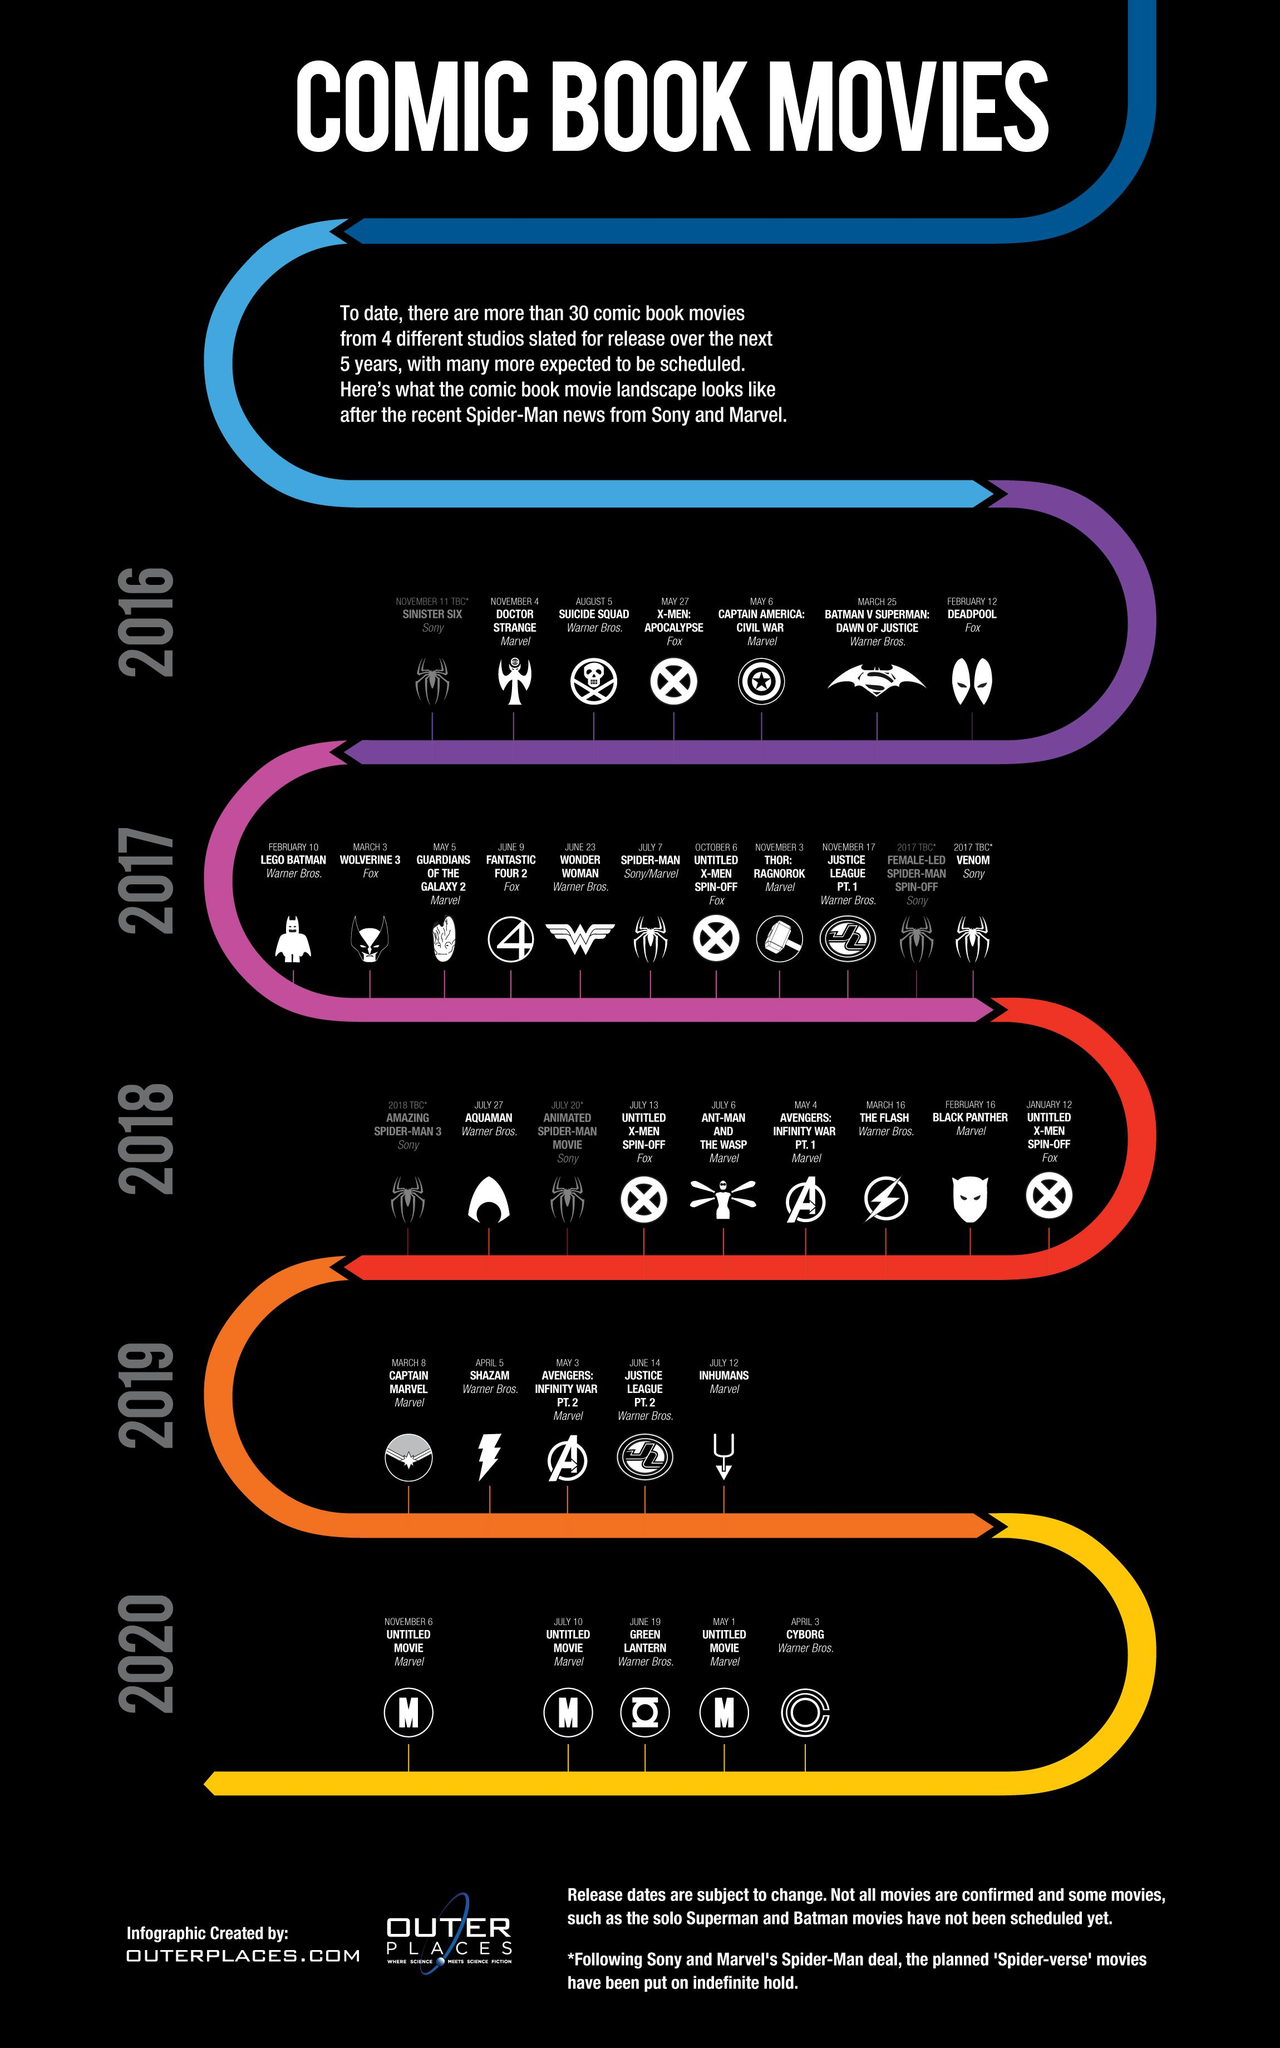Mention a couple of crucial points in this snapshot. As of 2020, three Marvel movies were planned to be released. In 2016, 2 comic books based on Fox-produced movies were scheduled for publication. 